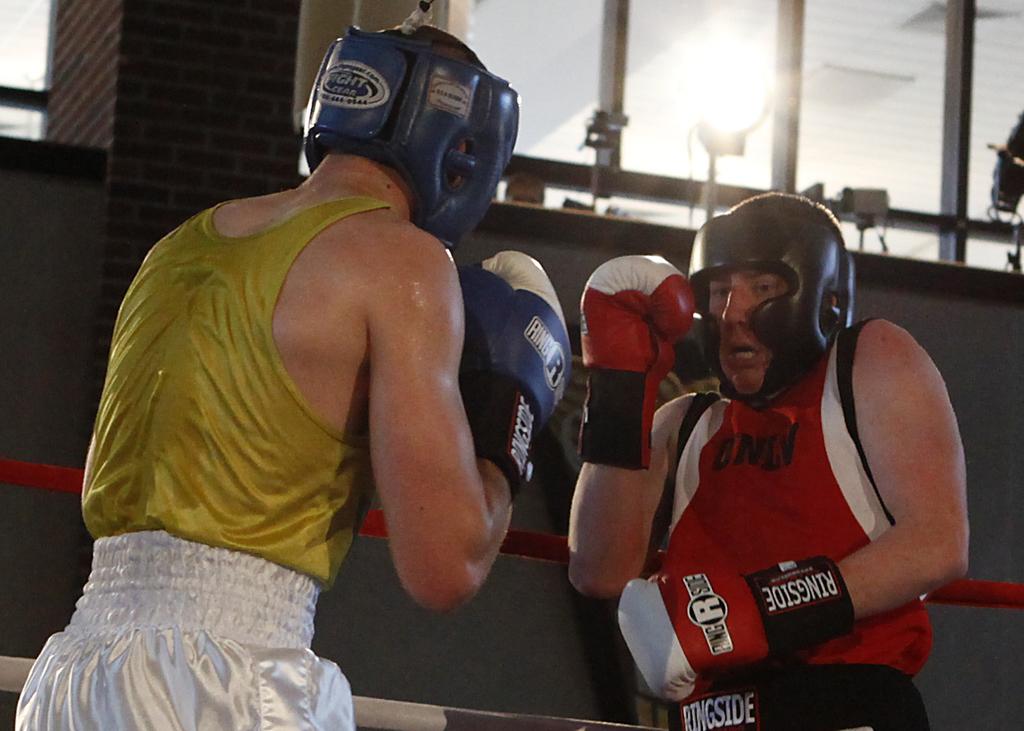What is written on the back of the headgear?
Your answer should be compact. Fight gear. 